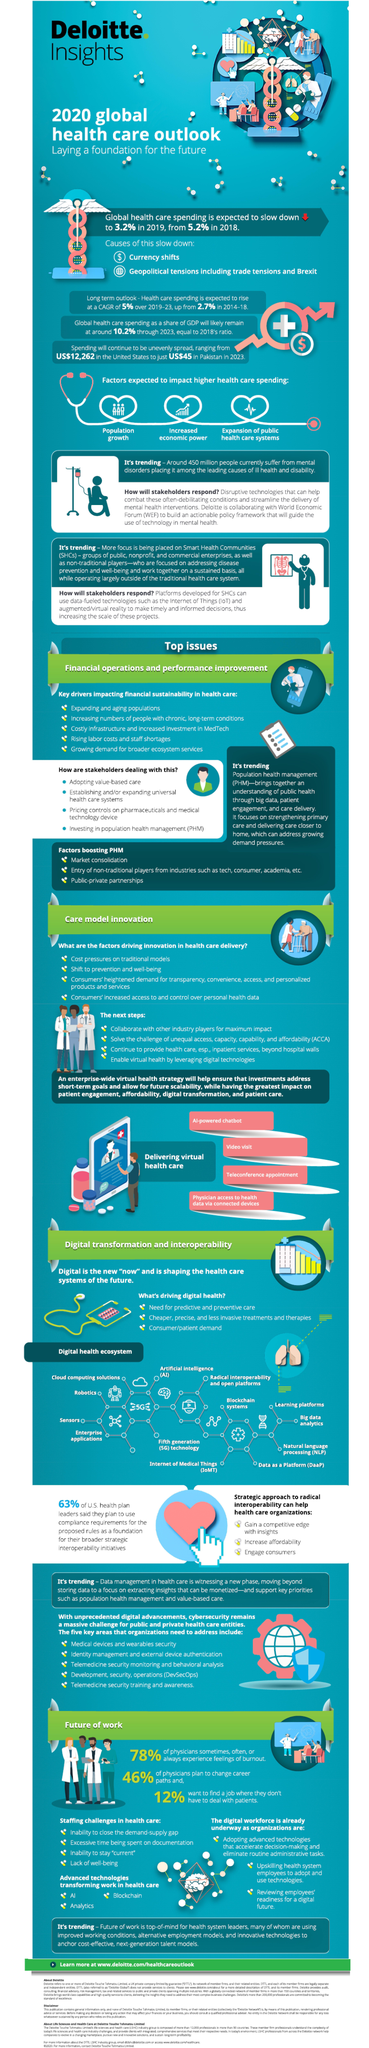By what percent is global health care spending expected to slow down during 2018-2019?
Answer the question with a short phrase. 2.0% What percent of physicians do not plan to change their career paths? 54% 